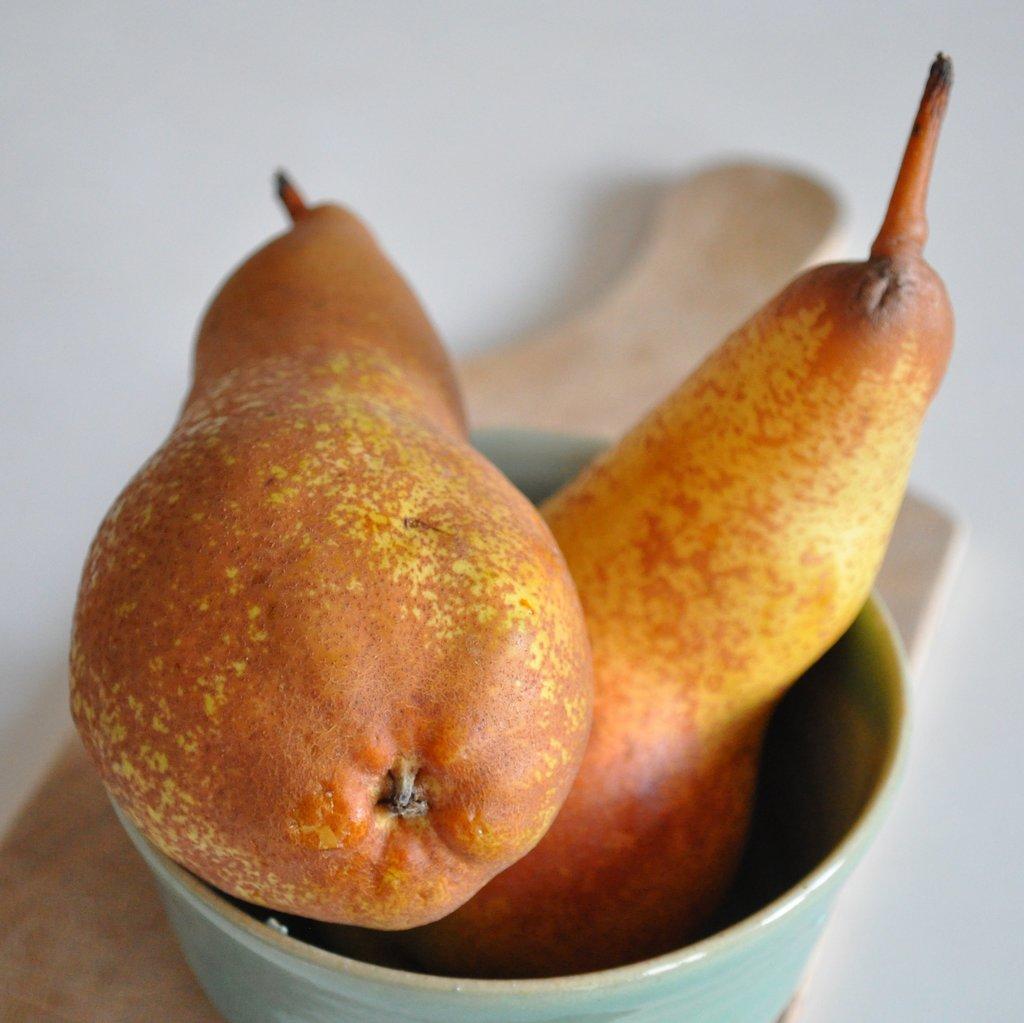Describe this image in one or two sentences. In this image I can see fruits in a bowl. They are in yellow,brown and orange color. Background is in white color. 